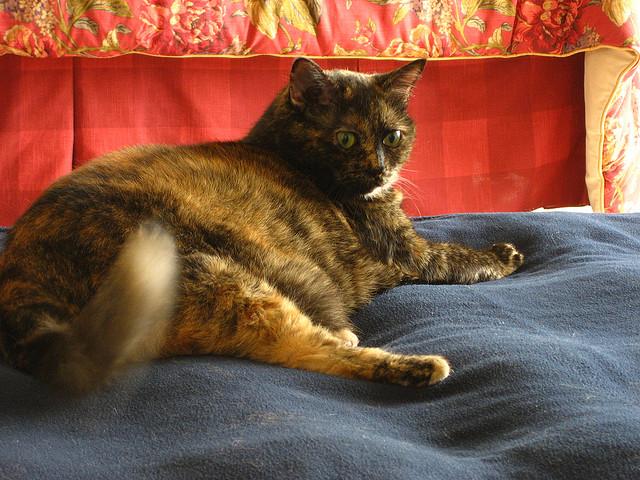Describe the emotion of the cat?
Give a very brief answer. Bored. Does the cat need to be on a diet?
Answer briefly. Yes. Is the tail moving?
Concise answer only. Yes. 